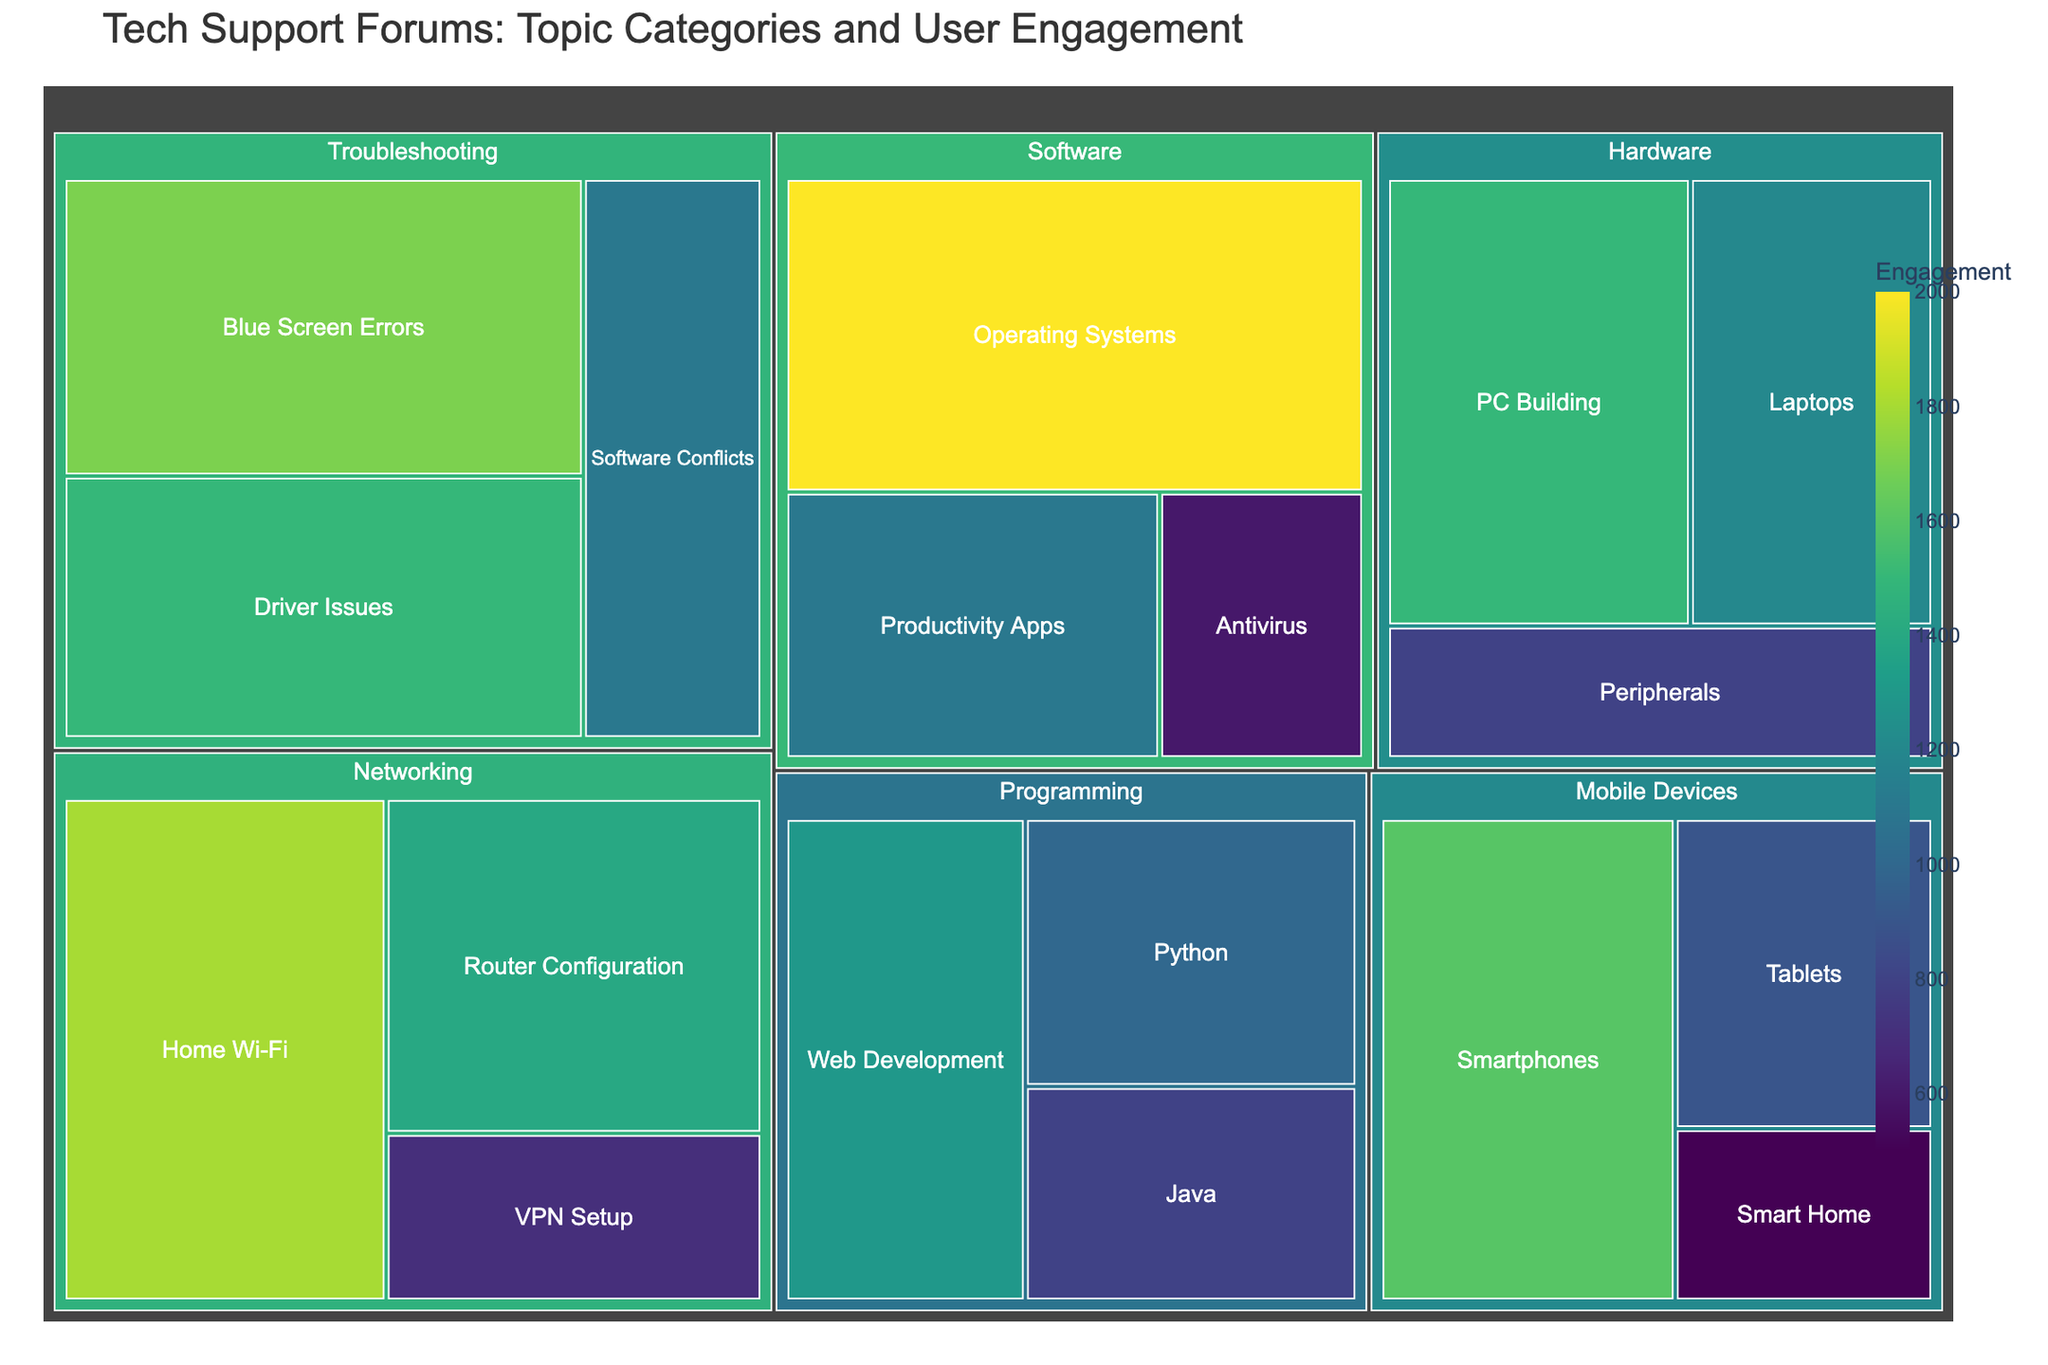What is the category with the highest user engagement? To find the category with the highest user engagement, look for the category with the largest box and darkest shade of color. In this treemap, "Software" has the highest engagement.
Answer: Software How many subcategories are there in the "Hardware" category? Count the number of boxes under the "Hardware" category in the treemap. There are three subcategories: PC Building, Laptops, and Peripherals.
Answer: 3 What is the total user engagement for the "Troubleshooting" category? Add the values of all subcategories under "Troubleshooting": Blue Screen Errors (1700) + Driver Issues (1500) + Software Conflicts (1100) = 4300.
Answer: 4300 Which subcategory within "Networking" has the least engagement? Within the "Networking" category, identify the subcategory with the smallest box and lightest color. "VPN Setup" has the least engagement with 700.
Answer: VPN Setup How does the user engagement of "Smartphones" compare to "Operating Systems"? Look at the engagement values for these subcategories. Smartphones have 1600, while Operating Systems have 2000. Operating Systems have more engagement than Smartphones.
Answer: Operating Systems What is the average engagement of all subcategories in the "Programming" category? Calculate the average by adding the user engagement for Web Development (1300), Python (1000), and Java (800), then divide by 3. (1300 + 1000 + 800) / 3 = 1033.33.
Answer: 1033.33 Which subcategory within "Mobile Devices" has the highest engagement? Identify the subcategory within "Mobile Devices" with the largest box and darkest shade. "Smartphones" has the highest engagement with 1600.
Answer: Smartphones How does the total engagement of "Networking" compare to "Mobile Devices"? Add the engagement values of all subcategories within these categories. Networking: Home Wi-Fi (1800) + Router Configuration (1400) + VPN Setup (700) = 3900. Mobile Devices: Smartphones (1600) + Tablets (900) + Smart Home (500) = 3000. Networking has more engagement than Mobile Devices.
Answer: Networking What is the most engaged subcategory within the "Software" category? Identify the subcategory within "Software" with the largest box. "Operating Systems" has the highest engagement with 2000.
Answer: Operating Systems 